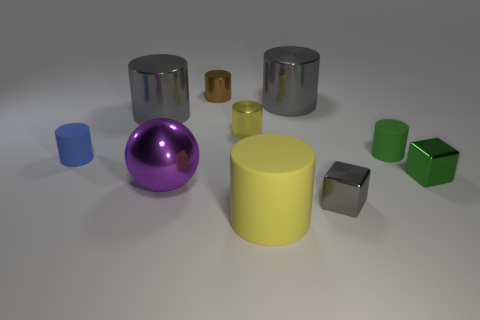There is a small metal object that is in front of the large purple shiny object; does it have the same shape as the small brown object?
Keep it short and to the point. No. Is the number of big purple metal things that are behind the tiny green matte object less than the number of big rubber objects that are behind the large rubber cylinder?
Provide a short and direct response. No. What is the tiny blue object made of?
Your answer should be very brief. Rubber. There is a big matte cylinder; does it have the same color as the tiny metal cylinder that is right of the brown cylinder?
Make the answer very short. Yes. What number of yellow cylinders are in front of the small green metallic thing?
Keep it short and to the point. 1. Are there fewer yellow rubber things behind the purple shiny thing than big gray metallic objects?
Give a very brief answer. Yes. The large matte cylinder is what color?
Keep it short and to the point. Yellow. There is a small metal cylinder that is in front of the tiny brown cylinder; does it have the same color as the large rubber thing?
Make the answer very short. Yes. The other small shiny object that is the same shape as the tiny gray object is what color?
Your answer should be very brief. Green. What number of large things are green matte cylinders or red shiny objects?
Give a very brief answer. 0. 